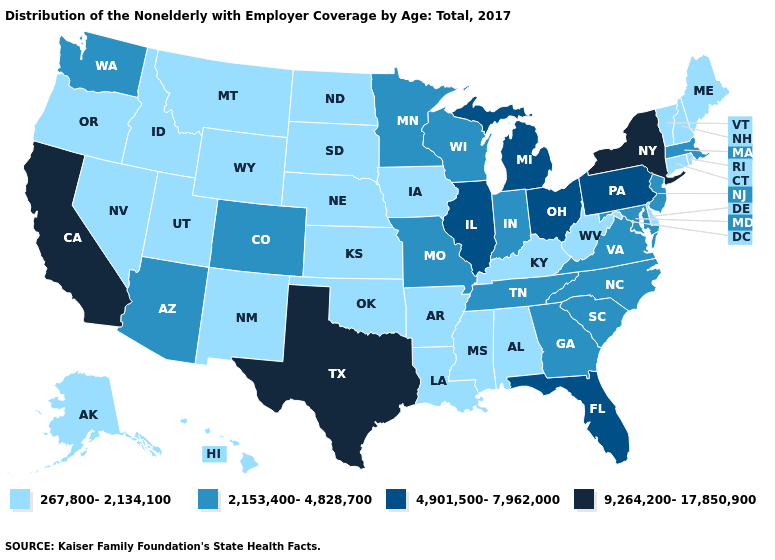Which states hav the highest value in the West?
Quick response, please. California. What is the lowest value in states that border North Carolina?
Answer briefly. 2,153,400-4,828,700. Name the states that have a value in the range 2,153,400-4,828,700?
Quick response, please. Arizona, Colorado, Georgia, Indiana, Maryland, Massachusetts, Minnesota, Missouri, New Jersey, North Carolina, South Carolina, Tennessee, Virginia, Washington, Wisconsin. Does Kansas have the lowest value in the MidWest?
Concise answer only. Yes. Is the legend a continuous bar?
Answer briefly. No. Name the states that have a value in the range 4,901,500-7,962,000?
Write a very short answer. Florida, Illinois, Michigan, Ohio, Pennsylvania. Name the states that have a value in the range 9,264,200-17,850,900?
Quick response, please. California, New York, Texas. Does Ohio have the lowest value in the USA?
Give a very brief answer. No. Does the map have missing data?
Be succinct. No. Does Rhode Island have the lowest value in the USA?
Keep it brief. Yes. What is the highest value in the USA?
Answer briefly. 9,264,200-17,850,900. What is the value of Arkansas?
Quick response, please. 267,800-2,134,100. What is the value of Nevada?
Quick response, please. 267,800-2,134,100. What is the value of Kansas?
Concise answer only. 267,800-2,134,100. Among the states that border Mississippi , does Tennessee have the highest value?
Answer briefly. Yes. 